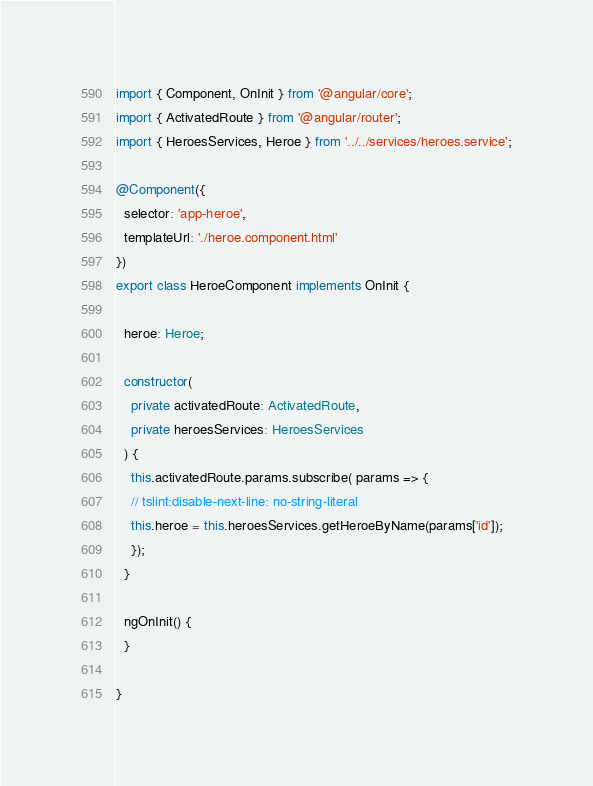Convert code to text. <code><loc_0><loc_0><loc_500><loc_500><_TypeScript_>import { Component, OnInit } from '@angular/core';
import { ActivatedRoute } from '@angular/router';
import { HeroesServices, Heroe } from '../../services/heroes.service';

@Component({
  selector: 'app-heroe',
  templateUrl: './heroe.component.html'
})
export class HeroeComponent implements OnInit {

  heroe: Heroe;

  constructor(
    private activatedRoute: ActivatedRoute,
    private heroesServices: HeroesServices
  ) {
    this.activatedRoute.params.subscribe( params => {
    // tslint:disable-next-line: no-string-literal
    this.heroe = this.heroesServices.getHeroeByName(params['id']);
    });
  }

  ngOnInit() {
  }

}
</code> 